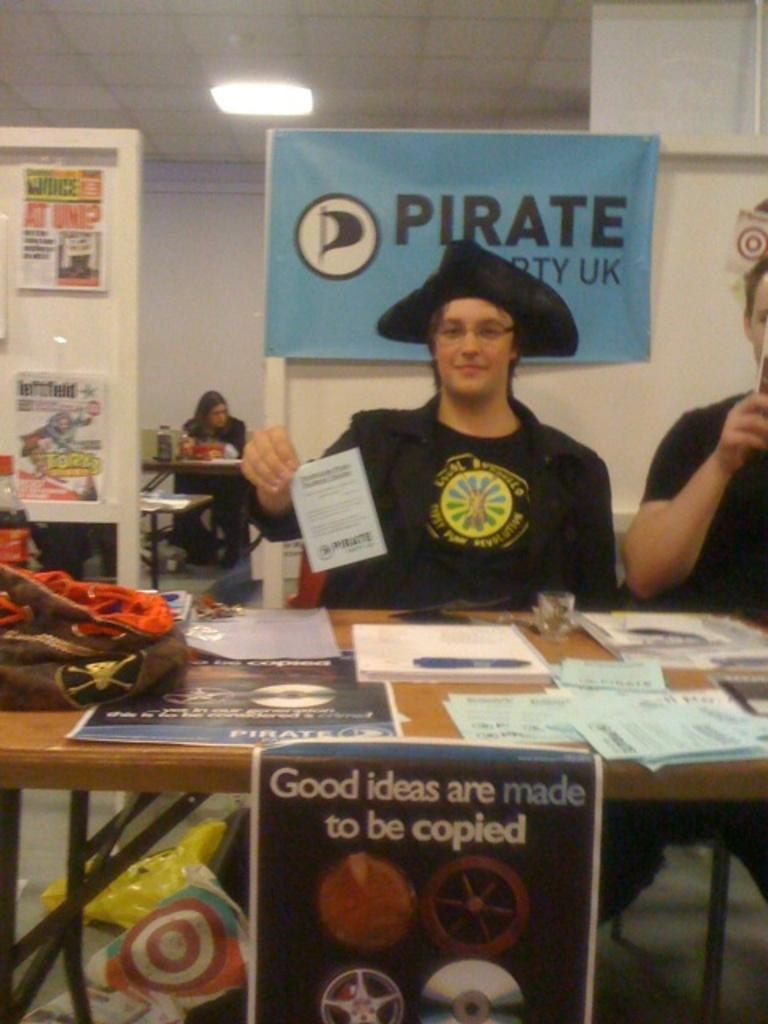<image>
Describe the image concisely. a man sitting at a table behind a poster that says 'good ideas are made to be copied' on it 